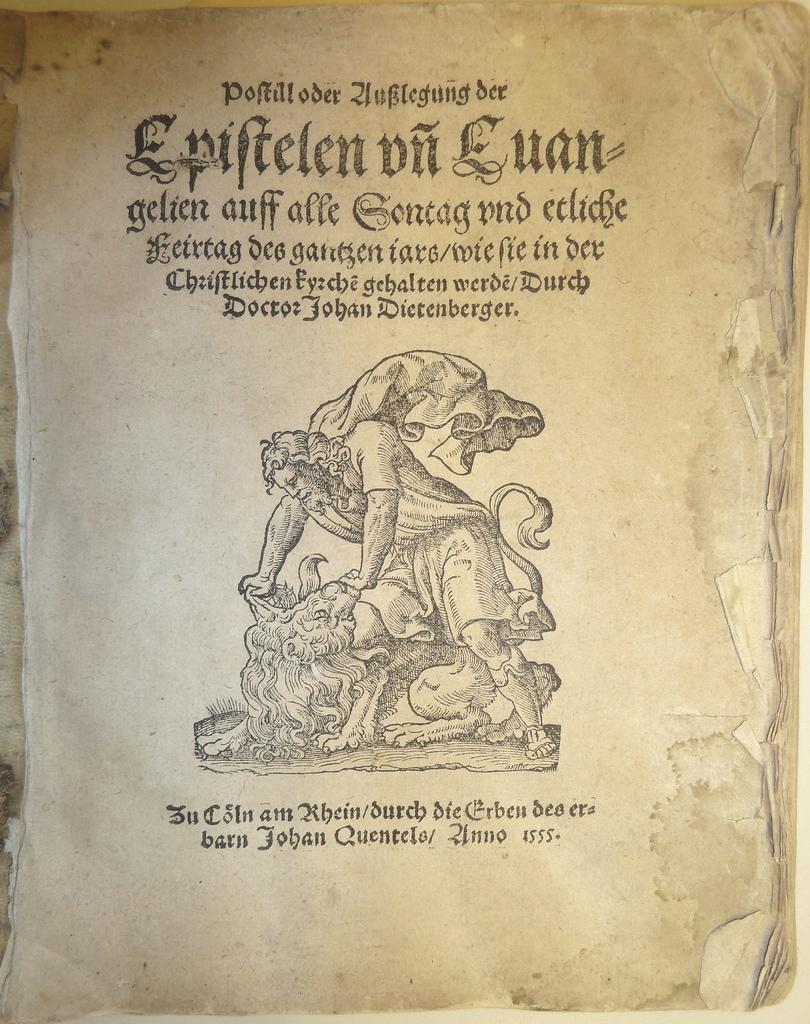What is the title of the book?
Provide a succinct answer. Epiftelen on euan. 